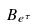Convert formula to latex. <formula><loc_0><loc_0><loc_500><loc_500>B _ { e ^ { \tau } }</formula> 